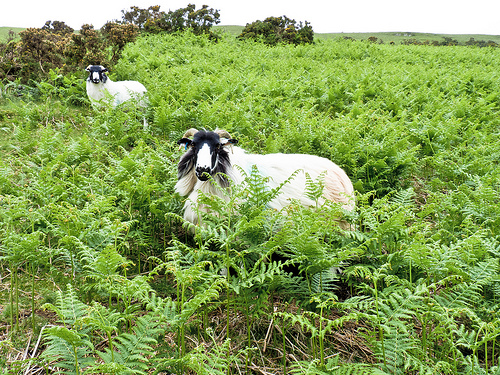Can you identify any signs of animal behavior in this setting? The relaxed posture of the goats, with one lying down and others grazing, indicates a peaceful environment. Their spread out positioning suggests ample grazing space and a lack of immediate threats. 